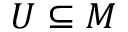Convert formula to latex. <formula><loc_0><loc_0><loc_500><loc_500>U \subseteq M</formula> 